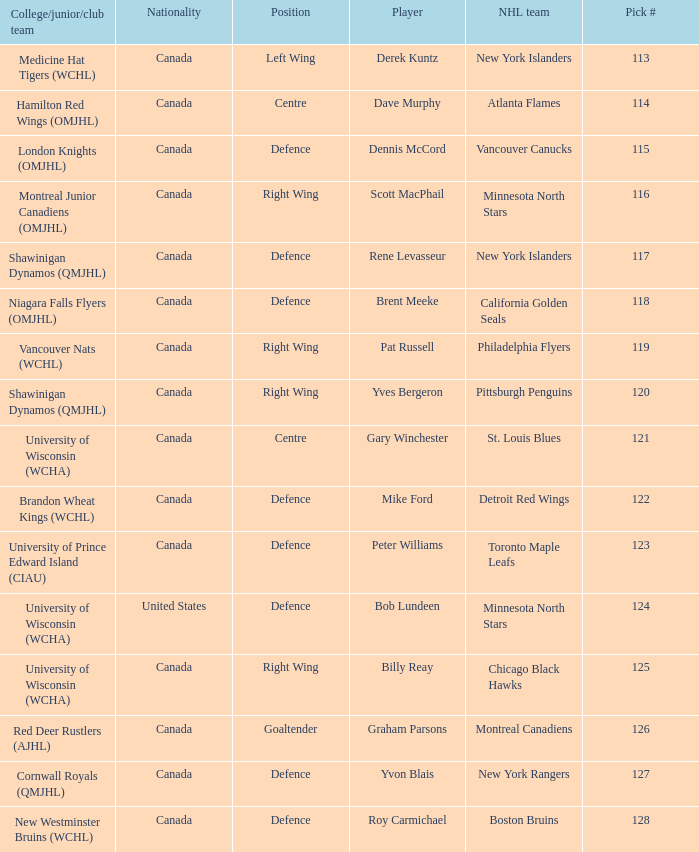Name the position for pick number 128 Defence. 